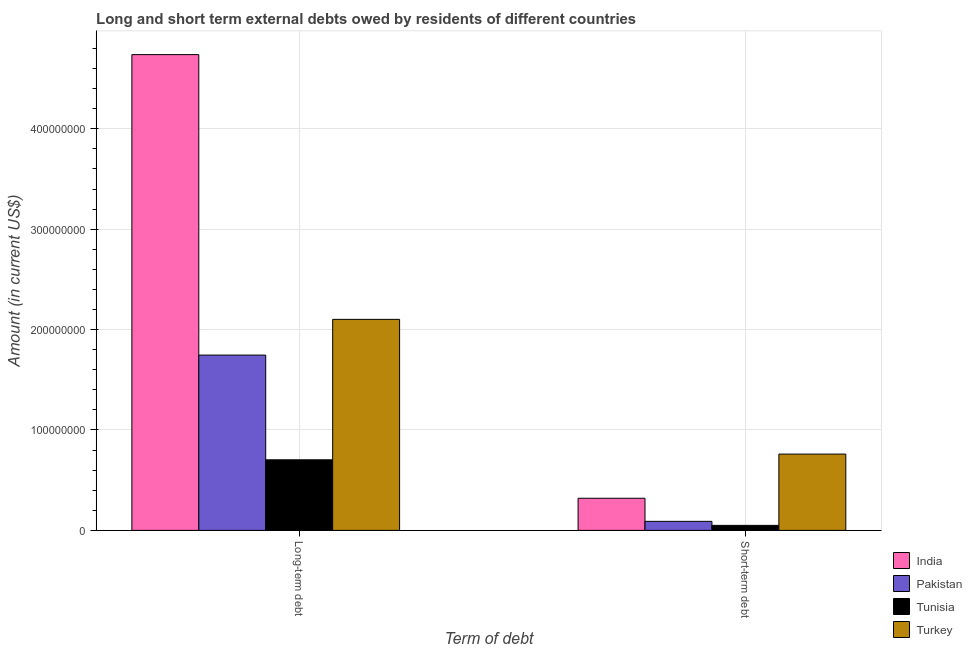How many different coloured bars are there?
Ensure brevity in your answer.  4. Are the number of bars on each tick of the X-axis equal?
Offer a very short reply. Yes. What is the label of the 1st group of bars from the left?
Make the answer very short. Long-term debt. What is the short-term debts owed by residents in Pakistan?
Your response must be concise. 9.00e+06. Across all countries, what is the maximum long-term debts owed by residents?
Provide a short and direct response. 4.74e+08. Across all countries, what is the minimum long-term debts owed by residents?
Your answer should be compact. 7.03e+07. In which country was the short-term debts owed by residents minimum?
Offer a very short reply. Tunisia. What is the total short-term debts owed by residents in the graph?
Offer a very short reply. 1.22e+08. What is the difference between the long-term debts owed by residents in India and that in Turkey?
Provide a succinct answer. 2.64e+08. What is the difference between the short-term debts owed by residents in India and the long-term debts owed by residents in Pakistan?
Offer a terse response. -1.43e+08. What is the average short-term debts owed by residents per country?
Make the answer very short. 3.05e+07. What is the difference between the long-term debts owed by residents and short-term debts owed by residents in Tunisia?
Offer a terse response. 6.53e+07. In how many countries, is the long-term debts owed by residents greater than 340000000 US$?
Your response must be concise. 1. What is the ratio of the short-term debts owed by residents in Turkey to that in Tunisia?
Keep it short and to the point. 15.2. In how many countries, is the long-term debts owed by residents greater than the average long-term debts owed by residents taken over all countries?
Offer a very short reply. 1. What does the 3rd bar from the left in Short-term debt represents?
Offer a very short reply. Tunisia. What does the 4th bar from the right in Long-term debt represents?
Provide a short and direct response. India. How many bars are there?
Your response must be concise. 8. Where does the legend appear in the graph?
Make the answer very short. Bottom right. What is the title of the graph?
Provide a short and direct response. Long and short term external debts owed by residents of different countries. What is the label or title of the X-axis?
Provide a succinct answer. Term of debt. What is the label or title of the Y-axis?
Your response must be concise. Amount (in current US$). What is the Amount (in current US$) in India in Long-term debt?
Make the answer very short. 4.74e+08. What is the Amount (in current US$) in Pakistan in Long-term debt?
Provide a succinct answer. 1.75e+08. What is the Amount (in current US$) in Tunisia in Long-term debt?
Your answer should be compact. 7.03e+07. What is the Amount (in current US$) of Turkey in Long-term debt?
Make the answer very short. 2.10e+08. What is the Amount (in current US$) of India in Short-term debt?
Offer a terse response. 3.20e+07. What is the Amount (in current US$) of Pakistan in Short-term debt?
Provide a short and direct response. 9.00e+06. What is the Amount (in current US$) of Turkey in Short-term debt?
Ensure brevity in your answer.  7.60e+07. Across all Term of debt, what is the maximum Amount (in current US$) in India?
Give a very brief answer. 4.74e+08. Across all Term of debt, what is the maximum Amount (in current US$) of Pakistan?
Offer a very short reply. 1.75e+08. Across all Term of debt, what is the maximum Amount (in current US$) in Tunisia?
Provide a succinct answer. 7.03e+07. Across all Term of debt, what is the maximum Amount (in current US$) in Turkey?
Your answer should be compact. 2.10e+08. Across all Term of debt, what is the minimum Amount (in current US$) in India?
Provide a short and direct response. 3.20e+07. Across all Term of debt, what is the minimum Amount (in current US$) in Pakistan?
Your answer should be compact. 9.00e+06. Across all Term of debt, what is the minimum Amount (in current US$) in Turkey?
Your answer should be very brief. 7.60e+07. What is the total Amount (in current US$) of India in the graph?
Your answer should be very brief. 5.06e+08. What is the total Amount (in current US$) of Pakistan in the graph?
Give a very brief answer. 1.84e+08. What is the total Amount (in current US$) of Tunisia in the graph?
Your answer should be compact. 7.53e+07. What is the total Amount (in current US$) in Turkey in the graph?
Your answer should be compact. 2.86e+08. What is the difference between the Amount (in current US$) of India in Long-term debt and that in Short-term debt?
Give a very brief answer. 4.42e+08. What is the difference between the Amount (in current US$) in Pakistan in Long-term debt and that in Short-term debt?
Provide a succinct answer. 1.66e+08. What is the difference between the Amount (in current US$) of Tunisia in Long-term debt and that in Short-term debt?
Keep it short and to the point. 6.53e+07. What is the difference between the Amount (in current US$) in Turkey in Long-term debt and that in Short-term debt?
Your response must be concise. 1.34e+08. What is the difference between the Amount (in current US$) in India in Long-term debt and the Amount (in current US$) in Pakistan in Short-term debt?
Offer a very short reply. 4.65e+08. What is the difference between the Amount (in current US$) of India in Long-term debt and the Amount (in current US$) of Tunisia in Short-term debt?
Keep it short and to the point. 4.69e+08. What is the difference between the Amount (in current US$) of India in Long-term debt and the Amount (in current US$) of Turkey in Short-term debt?
Provide a short and direct response. 3.98e+08. What is the difference between the Amount (in current US$) in Pakistan in Long-term debt and the Amount (in current US$) in Tunisia in Short-term debt?
Your answer should be compact. 1.70e+08. What is the difference between the Amount (in current US$) of Pakistan in Long-term debt and the Amount (in current US$) of Turkey in Short-term debt?
Provide a succinct answer. 9.86e+07. What is the difference between the Amount (in current US$) of Tunisia in Long-term debt and the Amount (in current US$) of Turkey in Short-term debt?
Ensure brevity in your answer.  -5.70e+06. What is the average Amount (in current US$) of India per Term of debt?
Keep it short and to the point. 2.53e+08. What is the average Amount (in current US$) in Pakistan per Term of debt?
Your answer should be compact. 9.18e+07. What is the average Amount (in current US$) of Tunisia per Term of debt?
Ensure brevity in your answer.  3.76e+07. What is the average Amount (in current US$) of Turkey per Term of debt?
Give a very brief answer. 1.43e+08. What is the difference between the Amount (in current US$) in India and Amount (in current US$) in Pakistan in Long-term debt?
Keep it short and to the point. 2.99e+08. What is the difference between the Amount (in current US$) of India and Amount (in current US$) of Tunisia in Long-term debt?
Offer a terse response. 4.04e+08. What is the difference between the Amount (in current US$) of India and Amount (in current US$) of Turkey in Long-term debt?
Your answer should be very brief. 2.64e+08. What is the difference between the Amount (in current US$) of Pakistan and Amount (in current US$) of Tunisia in Long-term debt?
Make the answer very short. 1.04e+08. What is the difference between the Amount (in current US$) in Pakistan and Amount (in current US$) in Turkey in Long-term debt?
Provide a short and direct response. -3.56e+07. What is the difference between the Amount (in current US$) of Tunisia and Amount (in current US$) of Turkey in Long-term debt?
Your answer should be very brief. -1.40e+08. What is the difference between the Amount (in current US$) of India and Amount (in current US$) of Pakistan in Short-term debt?
Offer a terse response. 2.30e+07. What is the difference between the Amount (in current US$) of India and Amount (in current US$) of Tunisia in Short-term debt?
Provide a succinct answer. 2.70e+07. What is the difference between the Amount (in current US$) of India and Amount (in current US$) of Turkey in Short-term debt?
Give a very brief answer. -4.40e+07. What is the difference between the Amount (in current US$) in Pakistan and Amount (in current US$) in Turkey in Short-term debt?
Ensure brevity in your answer.  -6.70e+07. What is the difference between the Amount (in current US$) in Tunisia and Amount (in current US$) in Turkey in Short-term debt?
Keep it short and to the point. -7.10e+07. What is the ratio of the Amount (in current US$) in India in Long-term debt to that in Short-term debt?
Your response must be concise. 14.81. What is the ratio of the Amount (in current US$) in Pakistan in Long-term debt to that in Short-term debt?
Offer a terse response. 19.4. What is the ratio of the Amount (in current US$) of Tunisia in Long-term debt to that in Short-term debt?
Offer a very short reply. 14.06. What is the ratio of the Amount (in current US$) of Turkey in Long-term debt to that in Short-term debt?
Provide a short and direct response. 2.77. What is the difference between the highest and the second highest Amount (in current US$) of India?
Your answer should be compact. 4.42e+08. What is the difference between the highest and the second highest Amount (in current US$) of Pakistan?
Ensure brevity in your answer.  1.66e+08. What is the difference between the highest and the second highest Amount (in current US$) in Tunisia?
Your answer should be very brief. 6.53e+07. What is the difference between the highest and the second highest Amount (in current US$) in Turkey?
Keep it short and to the point. 1.34e+08. What is the difference between the highest and the lowest Amount (in current US$) in India?
Offer a terse response. 4.42e+08. What is the difference between the highest and the lowest Amount (in current US$) in Pakistan?
Provide a succinct answer. 1.66e+08. What is the difference between the highest and the lowest Amount (in current US$) in Tunisia?
Provide a short and direct response. 6.53e+07. What is the difference between the highest and the lowest Amount (in current US$) of Turkey?
Keep it short and to the point. 1.34e+08. 